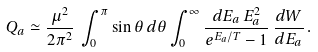Convert formula to latex. <formula><loc_0><loc_0><loc_500><loc_500>Q _ { a } \simeq \frac { \mu ^ { 2 } } { 2 \pi ^ { 2 } } \, \int ^ { \pi } _ { 0 } \sin \theta \, d \theta \int _ { 0 } ^ { \infty } \frac { d E _ { a } \, E _ { a } ^ { 2 } } { e ^ { E _ { a } / T } - 1 } \, \frac { d W } { d E _ { a } } \, .</formula> 